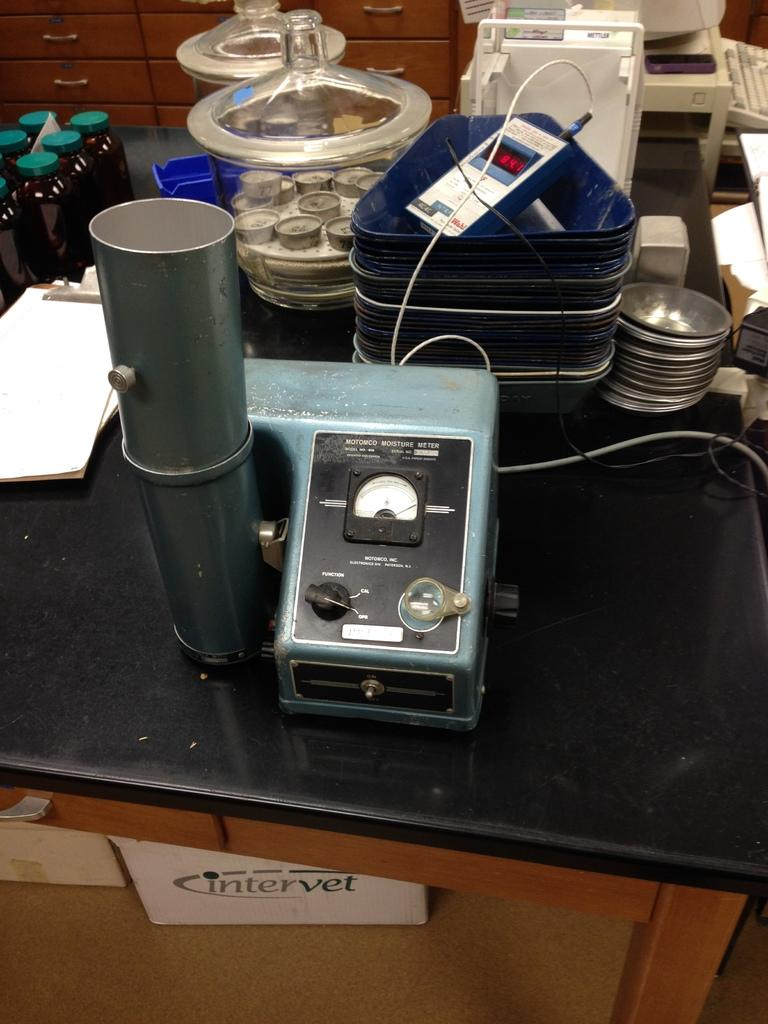<image>
Write a terse but informative summary of the picture. a box under a table that says intervet on it 